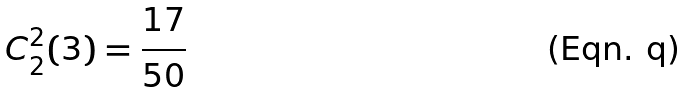<formula> <loc_0><loc_0><loc_500><loc_500>C _ { 2 } ^ { 2 } ( 3 ) = \frac { 1 7 } { 5 0 }</formula> 